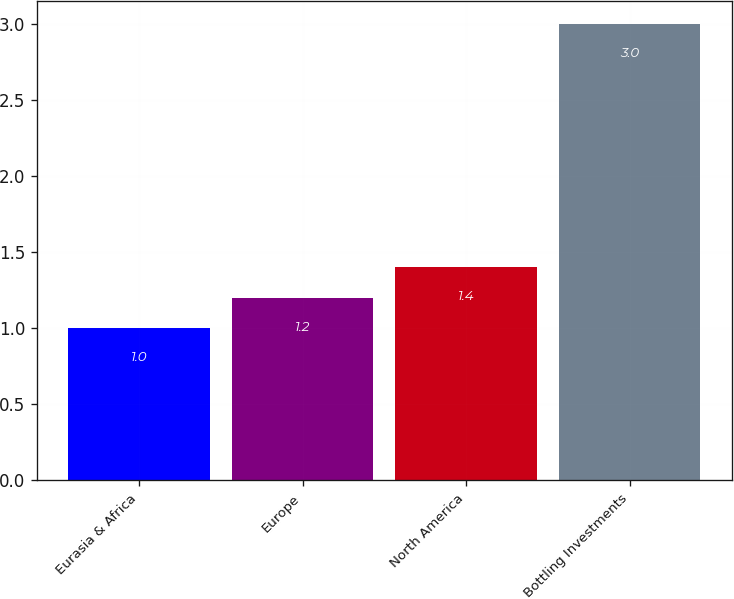Convert chart to OTSL. <chart><loc_0><loc_0><loc_500><loc_500><bar_chart><fcel>Eurasia & Africa<fcel>Europe<fcel>North America<fcel>Bottling Investments<nl><fcel>1<fcel>1.2<fcel>1.4<fcel>3<nl></chart> 